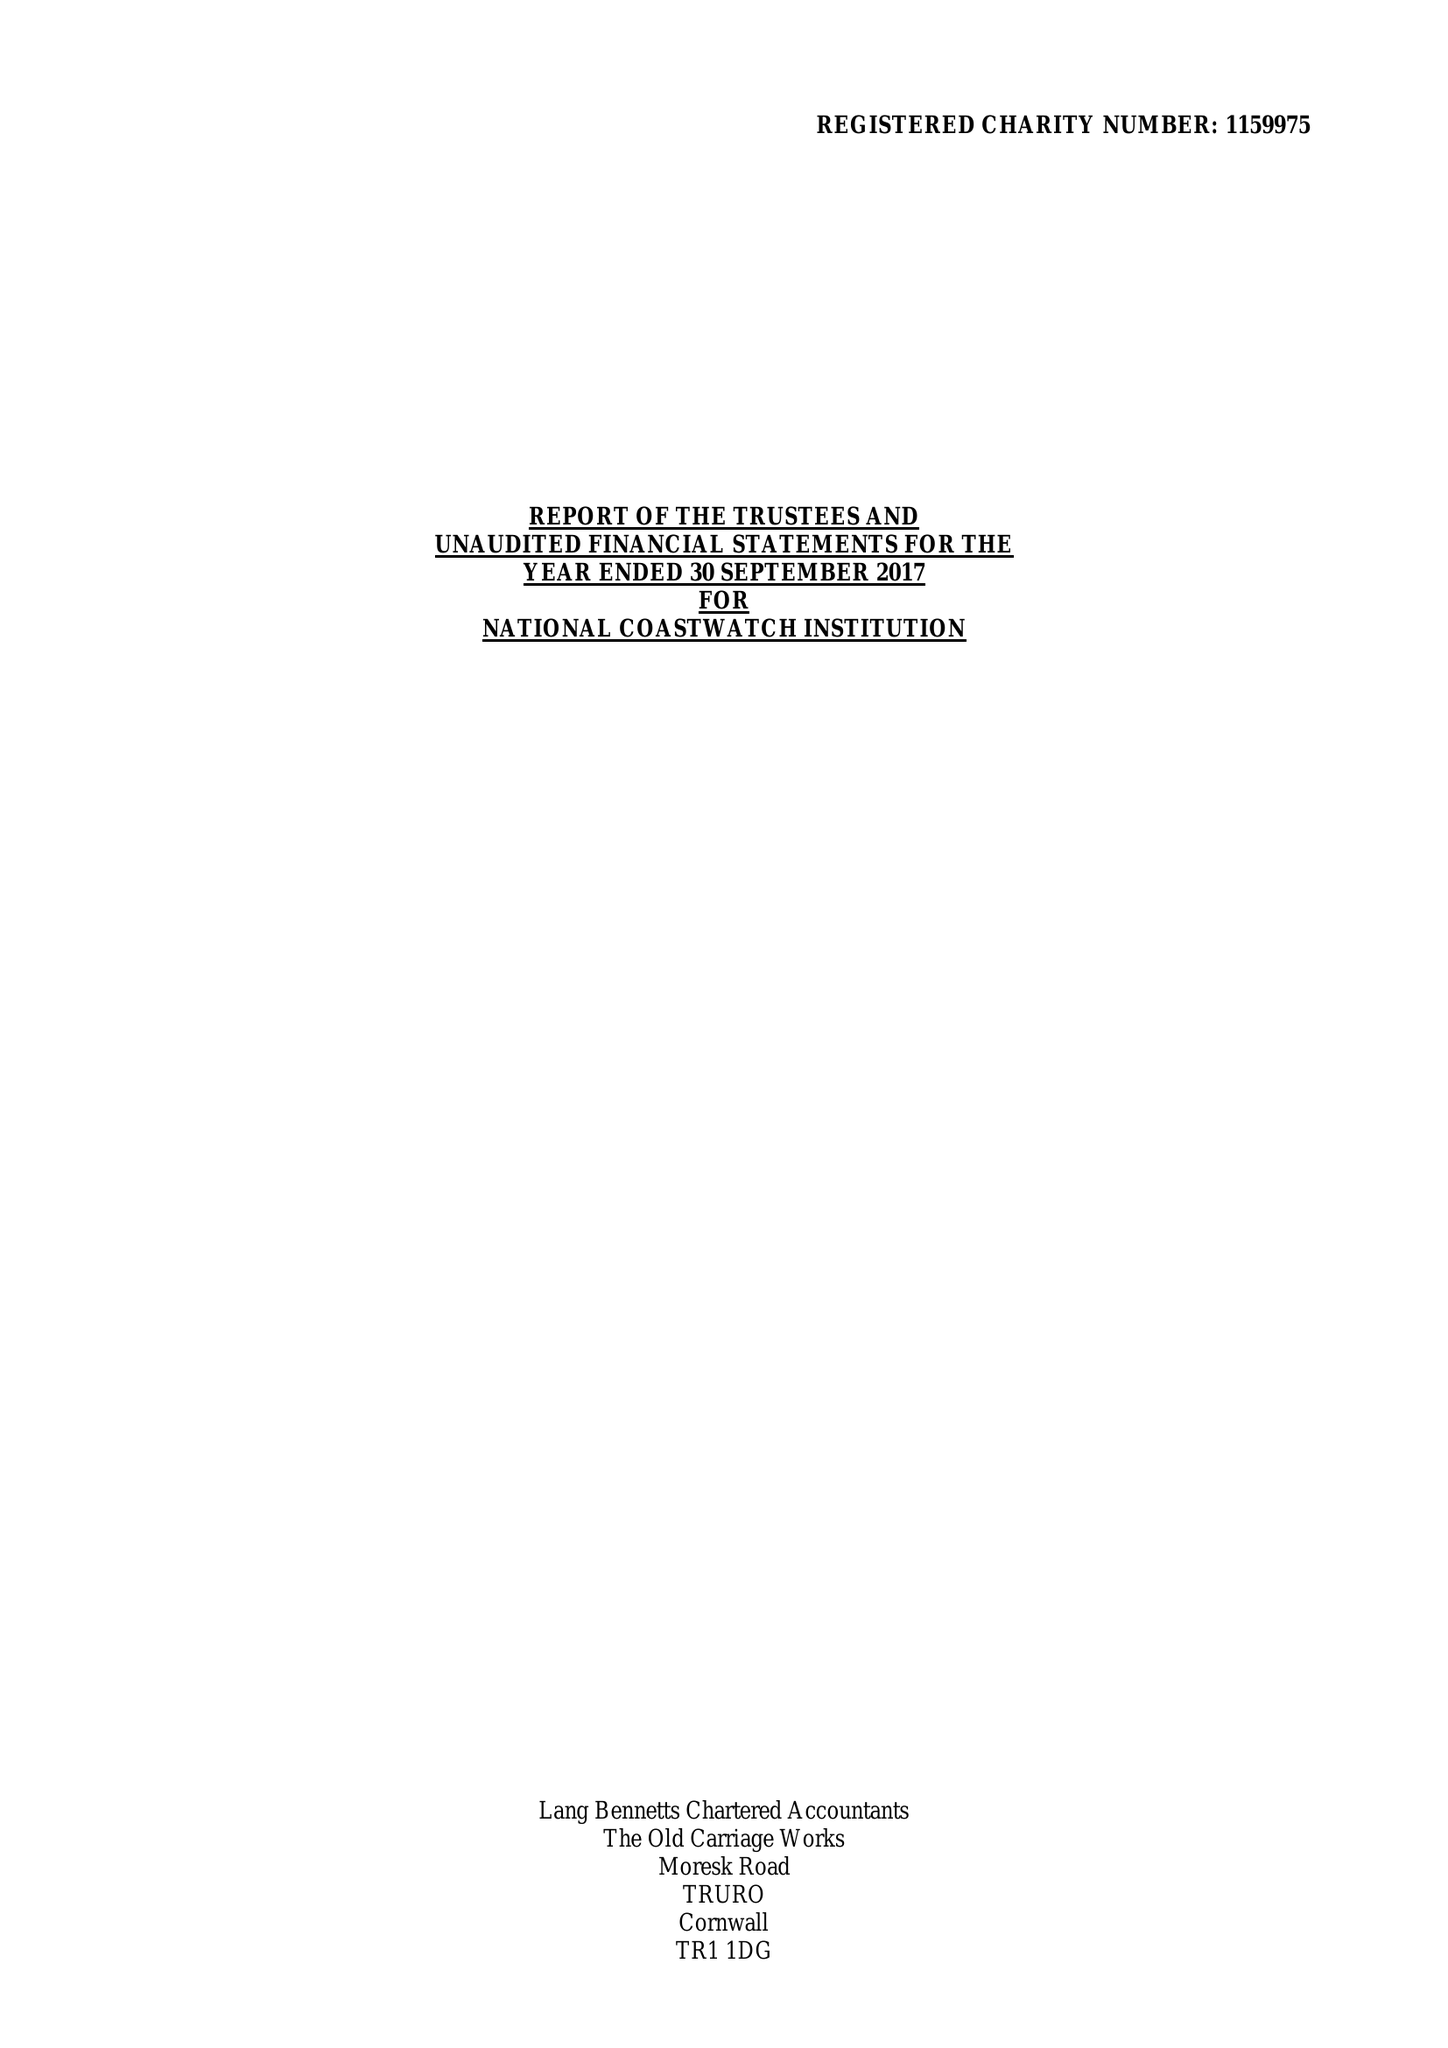What is the value for the income_annually_in_british_pounds?
Answer the question using a single word or phrase. 465551.00 